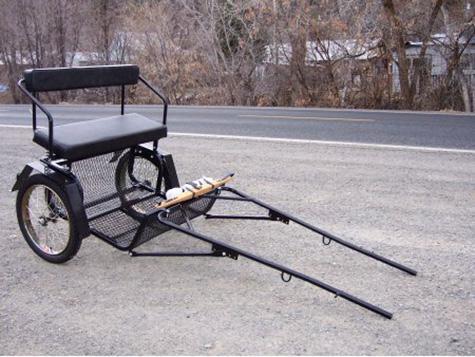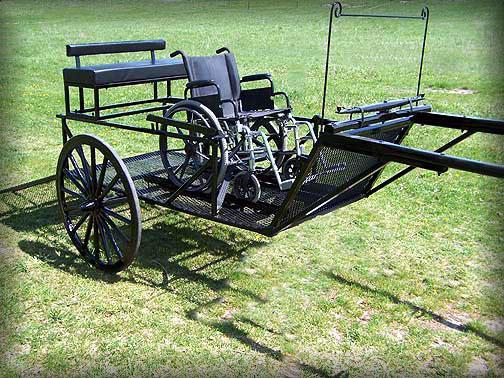The first image is the image on the left, the second image is the image on the right. Considering the images on both sides, is "There is a carriage next to a paved road in the left image." valid? Answer yes or no. Yes. The first image is the image on the left, the second image is the image on the right. For the images shown, is this caption "Both carriages are facing right." true? Answer yes or no. Yes. 